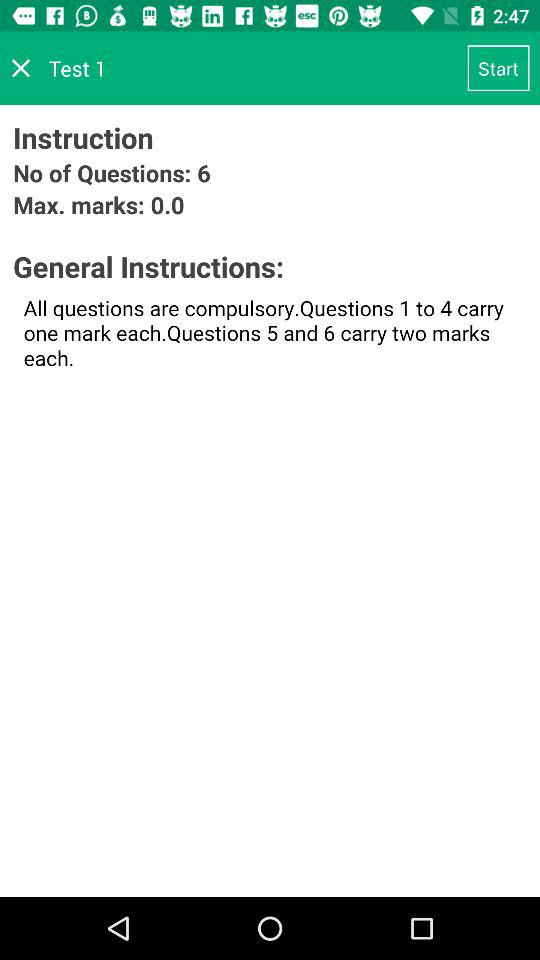How many questions are there? There are a total of 6 questions. 